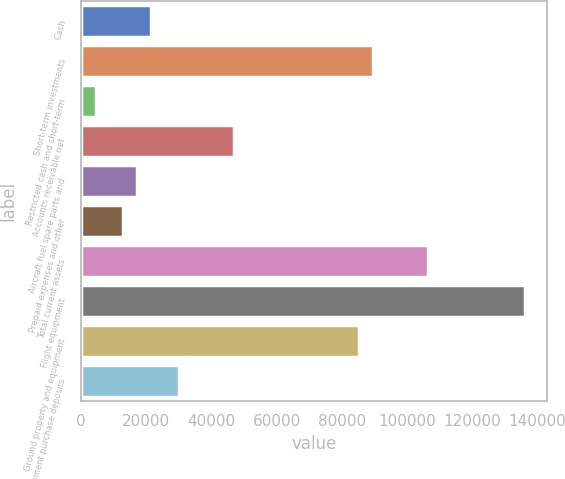<chart> <loc_0><loc_0><loc_500><loc_500><bar_chart><fcel>Cash<fcel>Short-term investments<fcel>Restricted cash and short-term<fcel>Accounts receivable net<fcel>Aircraft fuel spare parts and<fcel>Prepaid expenses and other<fcel>Total current assets<fcel>Flight equipment<fcel>Ground property and equipment<fcel>Equipment purchase deposits<nl><fcel>21556<fcel>89495.2<fcel>4571.2<fcel>47033.2<fcel>17309.8<fcel>13063.6<fcel>106480<fcel>136203<fcel>85249<fcel>30048.4<nl></chart> 